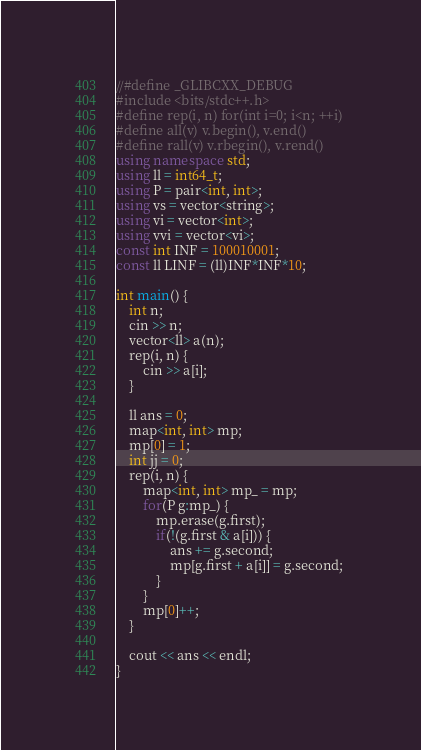<code> <loc_0><loc_0><loc_500><loc_500><_C++_>//#define _GLIBCXX_DEBUG
#include <bits/stdc++.h>
#define rep(i, n) for(int i=0; i<n; ++i)
#define all(v) v.begin(), v.end()
#define rall(v) v.rbegin(), v.rend()
using namespace std;
using ll = int64_t;
using P = pair<int, int>;
using vs = vector<string>;
using vi = vector<int>;
using vvi = vector<vi>;
const int INF = 100010001;
const ll LINF = (ll)INF*INF*10;

int main() {
    int n;
    cin >> n;
    vector<ll> a(n);
    rep(i, n) {
        cin >> a[i];
    }

    ll ans = 0;
    map<int, int> mp;
    mp[0] = 1;
    int jj = 0;
    rep(i, n) {
        map<int, int> mp_ = mp;
        for(P g:mp_) {
            mp.erase(g.first);
            if(!(g.first & a[i])) {
                ans += g.second;
                mp[g.first + a[i]] = g.second; 
            }
        }
        mp[0]++;
    }

    cout << ans << endl;
}
</code> 